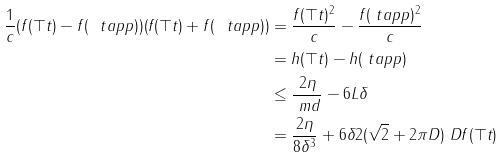Convert formula to latex. <formula><loc_0><loc_0><loc_500><loc_500>\frac { 1 } { c } ( f ( \top t ) - f ( \ t a p p ) ) ( f ( \top t ) + f ( \ t a p p ) ) & = \frac { f ( \top t ) ^ { 2 } } { c } - \frac { f ( \ t a p p ) ^ { 2 } } { c } \\ & = h ( \top t ) - h ( \ t a p p ) \\ & \leq \frac { 2 \eta } { \ m d } - 6 L \delta \\ & = \frac { 2 \eta } { 8 \delta ^ { 3 } } + 6 \delta 2 ( \sqrt { 2 } + 2 \pi D ) \ D f ( \top t )</formula> 